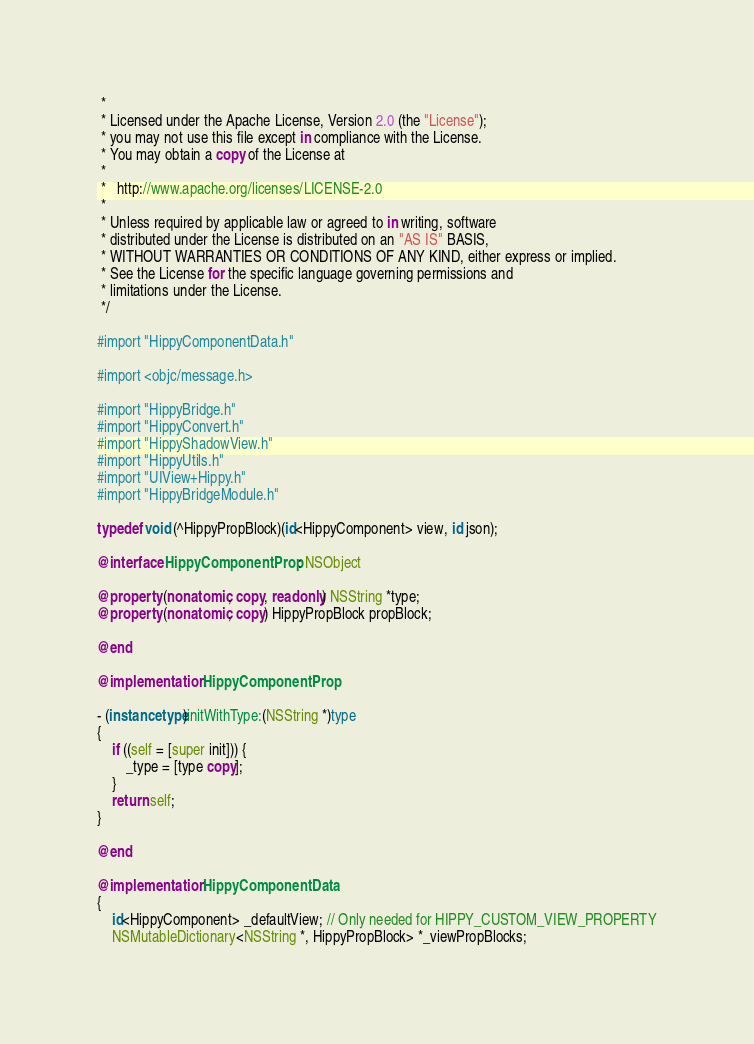<code> <loc_0><loc_0><loc_500><loc_500><_ObjectiveC_> *
 * Licensed under the Apache License, Version 2.0 (the "License");
 * you may not use this file except in compliance with the License.
 * You may obtain a copy of the License at
 *
 *   http://www.apache.org/licenses/LICENSE-2.0
 *
 * Unless required by applicable law or agreed to in writing, software
 * distributed under the License is distributed on an "AS IS" BASIS,
 * WITHOUT WARRANTIES OR CONDITIONS OF ANY KIND, either express or implied.
 * See the License for the specific language governing permissions and
 * limitations under the License.
 */

#import "HippyComponentData.h"

#import <objc/message.h>

#import "HippyBridge.h"
#import "HippyConvert.h"
#import "HippyShadowView.h"
#import "HippyUtils.h"
#import "UIView+Hippy.h"
#import "HippyBridgeModule.h"

typedef void (^HippyPropBlock)(id<HippyComponent> view, id json);

@interface HippyComponentProp : NSObject

@property (nonatomic, copy, readonly) NSString *type;
@property (nonatomic, copy) HippyPropBlock propBlock;

@end

@implementation HippyComponentProp

- (instancetype)initWithType:(NSString *)type
{
    if ((self = [super init])) {
        _type = [type copy];
    }
    return self;
}

@end

@implementation HippyComponentData
{
    id<HippyComponent> _defaultView; // Only needed for HIPPY_CUSTOM_VIEW_PROPERTY
    NSMutableDictionary<NSString *, HippyPropBlock> *_viewPropBlocks;</code> 